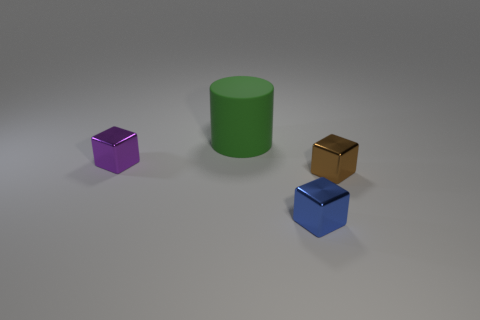Add 3 large brown things. How many objects exist? 7 Subtract all blocks. How many objects are left? 1 Add 4 green cylinders. How many green cylinders are left? 5 Add 4 purple cubes. How many purple cubes exist? 5 Subtract 1 blue blocks. How many objects are left? 3 Subtract all brown rubber cylinders. Subtract all metal cubes. How many objects are left? 1 